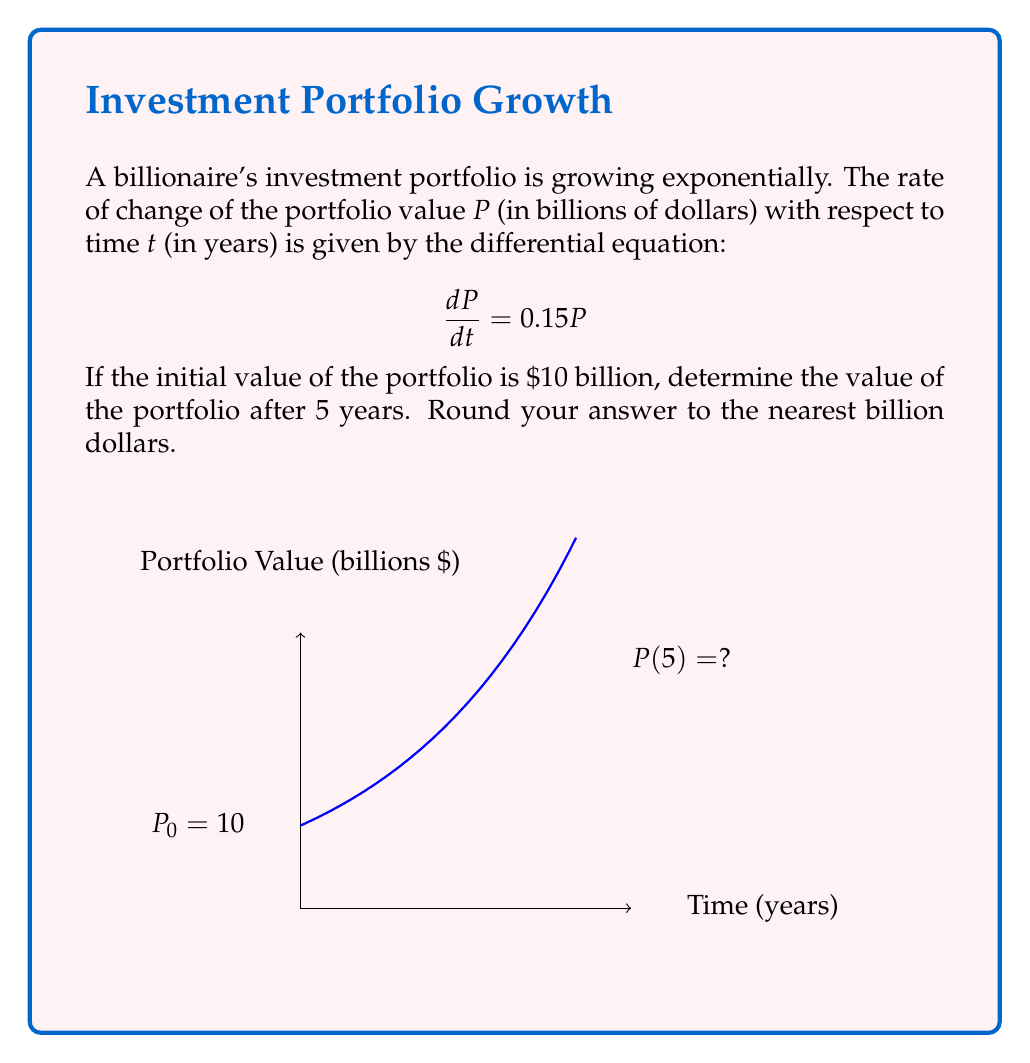Show me your answer to this math problem. Let's solve this step-by-step:

1) We have the differential equation $\frac{dP}{dt} = 0.15P$ with initial condition $P(0) = 10$.

2) This is a separable differential equation. We can rewrite it as:
   $$\frac{dP}{P} = 0.15dt$$

3) Integrating both sides:
   $$\int \frac{dP}{P} = \int 0.15dt$$
   $$\ln|P| = 0.15t + C$$

4) Applying the exponential function to both sides:
   $$P = e^{0.15t + C} = e^C \cdot e^{0.15t}$$

5) Let $A = e^C$. Then our general solution is:
   $$P = A \cdot e^{0.15t}$$

6) Using the initial condition $P(0) = 10$:
   $$10 = A \cdot e^{0.15 \cdot 0} = A$$

7) Therefore, our particular solution is:
   $$P = 10 \cdot e^{0.15t}$$

8) To find the value after 5 years, we calculate $P(5)$:
   $$P(5) = 10 \cdot e^{0.15 \cdot 5} = 10 \cdot e^{0.75} \approx 21.1$$

9) Rounding to the nearest billion:
   $$P(5) \approx 21 \text{ billion dollars}$$
Answer: $21 billion 